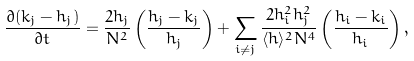<formula> <loc_0><loc_0><loc_500><loc_500>\frac { \partial ( k _ { j } - h _ { j } ) } { \partial t } = \frac { 2 h _ { j } } { N ^ { 2 } } \left ( \frac { h _ { j } - k _ { j } } { h _ { j } } \right ) + \sum _ { i \neq j } \frac { 2 h _ { i } ^ { 2 } h _ { j } ^ { 2 } } { \langle h \rangle ^ { 2 } N ^ { 4 } } \left ( \frac { h _ { i } - k _ { i } } { h _ { i } } \right ) ,</formula> 